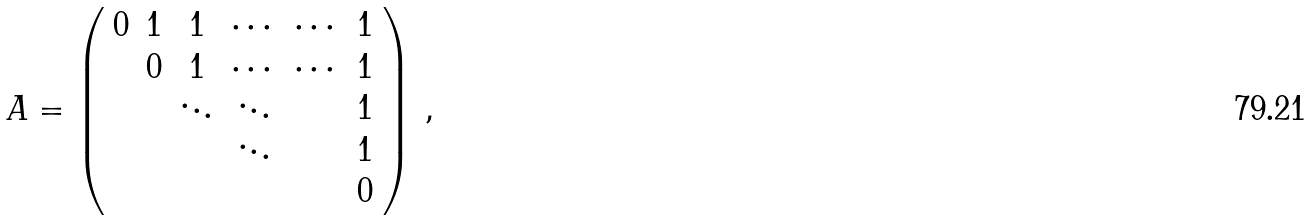Convert formula to latex. <formula><loc_0><loc_0><loc_500><loc_500>A = \left ( \begin{array} { c c c c c c } 0 & 1 & 1 & \cdots & \cdots & 1 \\ & 0 & 1 & \cdots & \cdots & 1 \\ & & \ddots & \ddots & & 1 \\ & & & \ddots & & 1 \\ & & & & & 0 \end{array} \right ) \, ,</formula> 